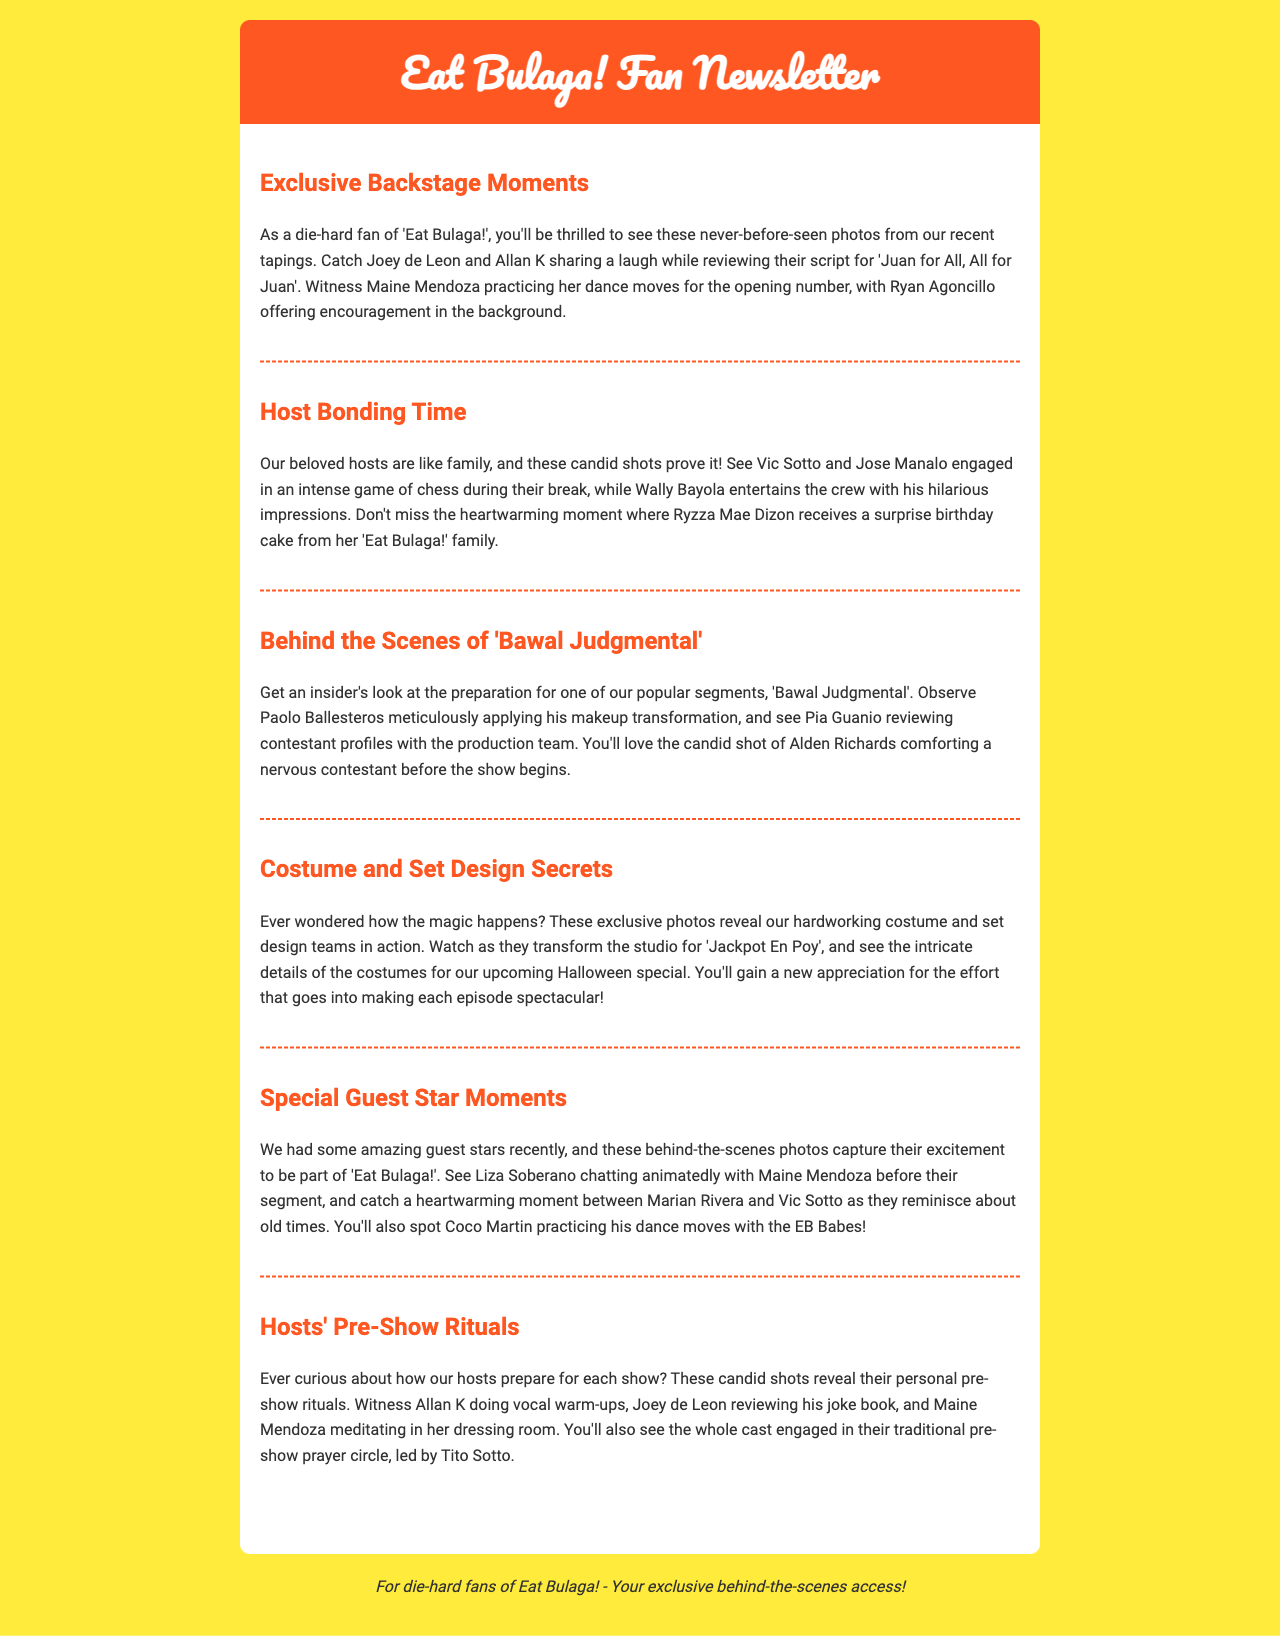What is the title of the first section? The first section is titled "Exclusive Backstage Moments" as stated in the document's header.
Answer: Exclusive Backstage Moments Who is seen practicing dance moves in the backstage moment? The document mentions that Maine Mendoza is practicing her dance moves.
Answer: Maine Mendoza What segment features Paolo Ballesteros preparing for makeup? The segment mentioned is "Bawal Judgmental" where Paolo Ballesteros is preparing.
Answer: Bawal Judgmental Which host is noted for doing vocal warm-ups? Allan K is observed doing vocal warm-ups before the show.
Answer: Allan K What type of game do Vic Sotto and Jose Manalo play during their break? The document states that Vic Sotto and Jose Manalo engage in a game of chess during their break.
Answer: Chess What is the main focus of the section titled "Costume and Set Design Secrets"? This section focuses on the costume and set design teams and their efforts in transforming the studio.
Answer: Costume and Set Design Who leads the pre-show prayer circle? Tito Sotto is mentioned as leading the pre-show prayer circle among the cast.
Answer: Tito Sotto What emotion does Alden Richards display in the segment preparation? Alden Richards is noted for comforting a nervous contestant, showing support.
Answer: Comforting support Which guest star was seen chatting with Maine Mendoza? Liza Soberano is seen chatting animatedly with Maine Mendoza in the backstage photos.
Answer: Liza Soberano 